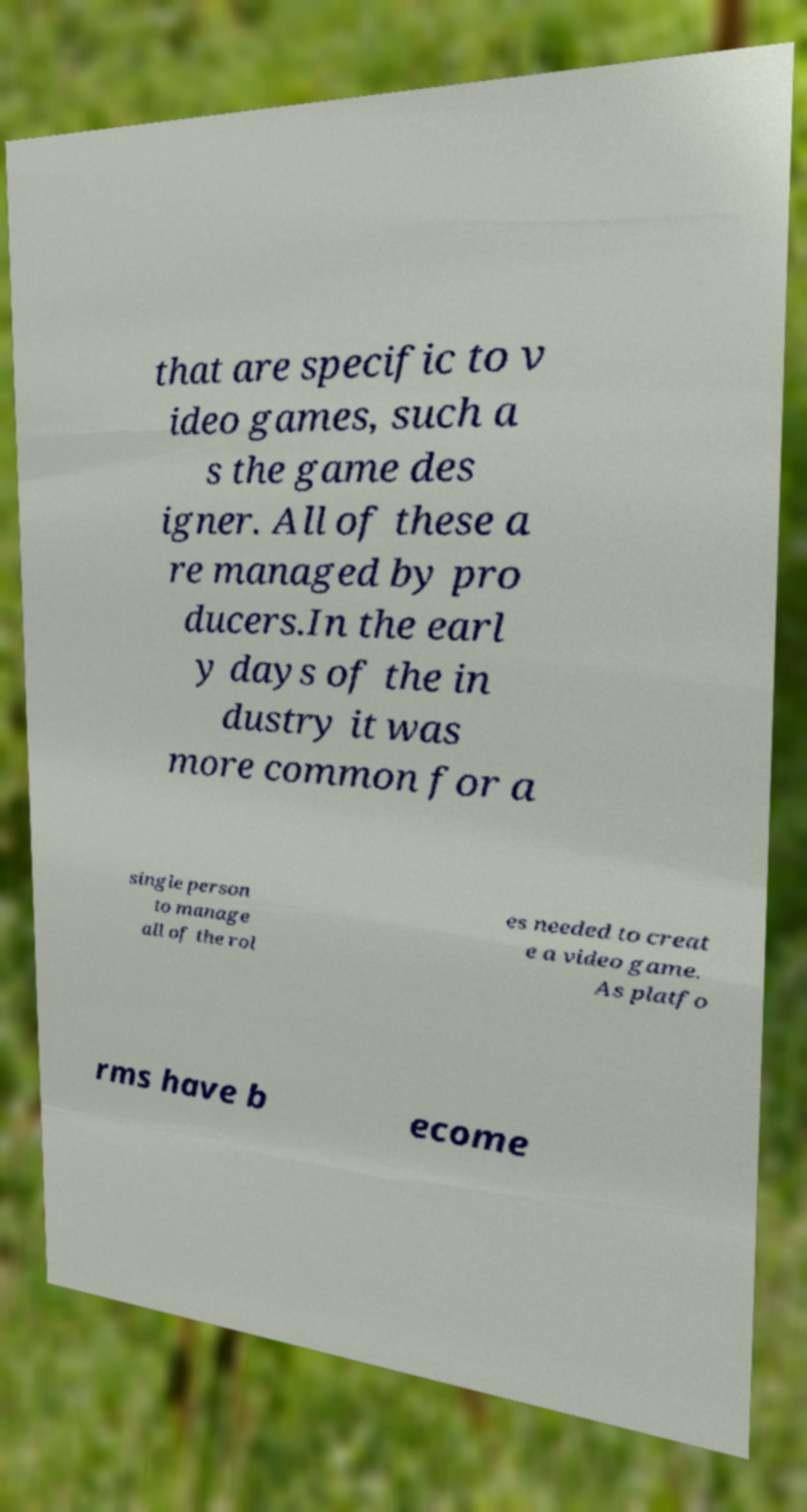Can you accurately transcribe the text from the provided image for me? that are specific to v ideo games, such a s the game des igner. All of these a re managed by pro ducers.In the earl y days of the in dustry it was more common for a single person to manage all of the rol es needed to creat e a video game. As platfo rms have b ecome 